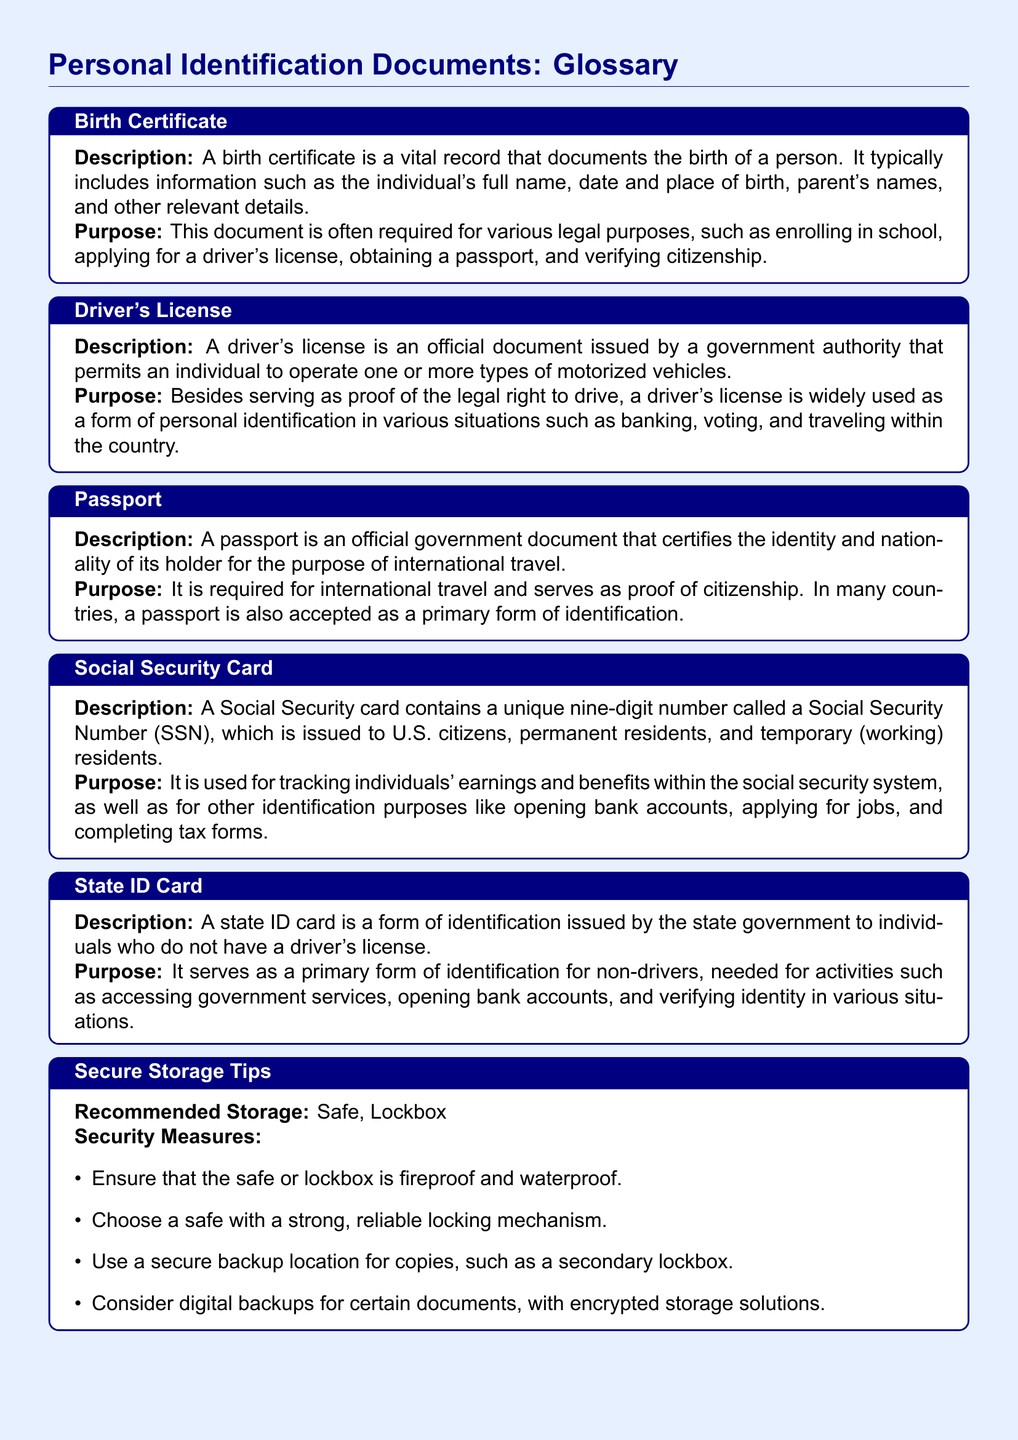What document certifies identity and nationality for international travel? The document that certifies identity and nationality for international travel is the passport, mentioned specifically in the glossary.
Answer: passport What is a unique number on a Social Security card? The unique number on a Social Security card is called the Social Security Number (SSN), which is specifically mentioned in the document.
Answer: Social Security Number (SSN) What is the purpose of a birth certificate? The purpose of a birth certificate is to verify citizenship and is required for legal purposes such as enrolling in school, as described in the document.
Answer: Verify citizenship What type of identification is issued to non-drivers? The document that serves as identification for non-drivers is the state ID card, clearly stated in the glossary.
Answer: state ID card What should the storage of personal identification documents be? The recommended storage for personal identification documents is a safe or lockbox, which is directly outlined in the secure storage tips section of the document.
Answer: Safe, Lockbox What is a key security measure for storing documents? A key security measure for storing documents is to ensure that the safe or lockbox is fireproof and waterproof, as listed in the document.
Answer: Fireproof and waterproof What is commonly required to obtain a passport? The document specifies that the passport is required for international travel and serves as proof of citizenship.
Answer: International travel What contains a vital record that documents birth? The document that contains a vital record documenting birth is the birth certificate, described in the glossary.
Answer: birth certificate 